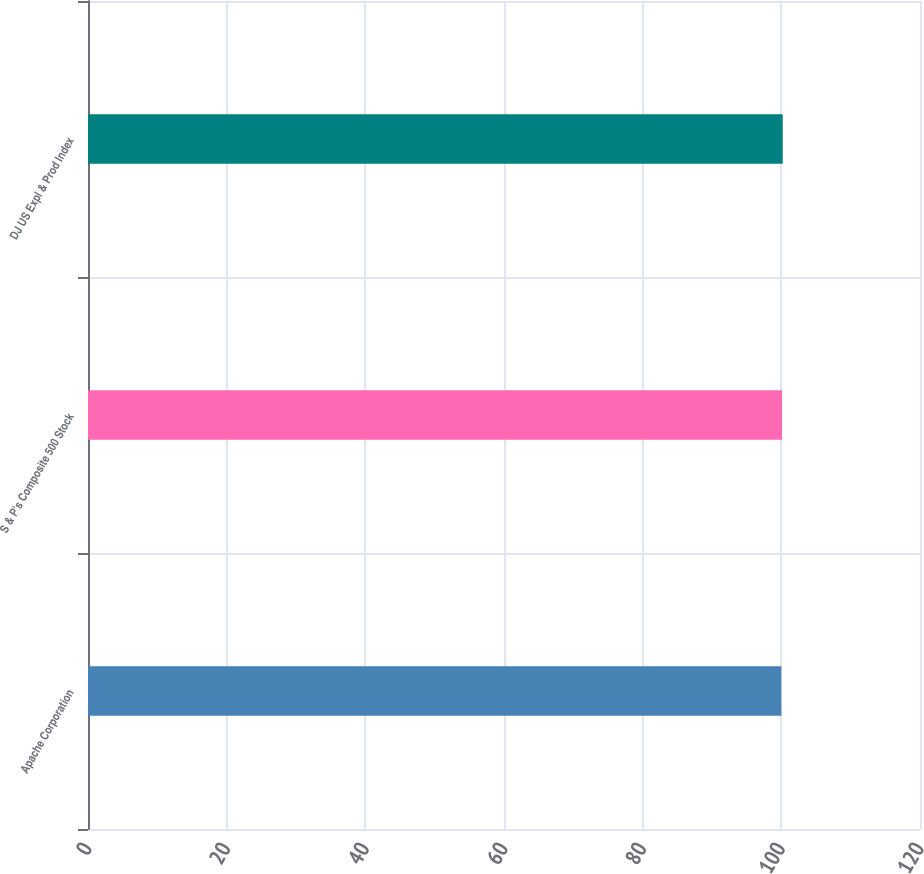Convert chart to OTSL. <chart><loc_0><loc_0><loc_500><loc_500><bar_chart><fcel>Apache Corporation<fcel>S & P's Composite 500 Stock<fcel>DJ US Expl & Prod Index<nl><fcel>100<fcel>100.1<fcel>100.2<nl></chart> 